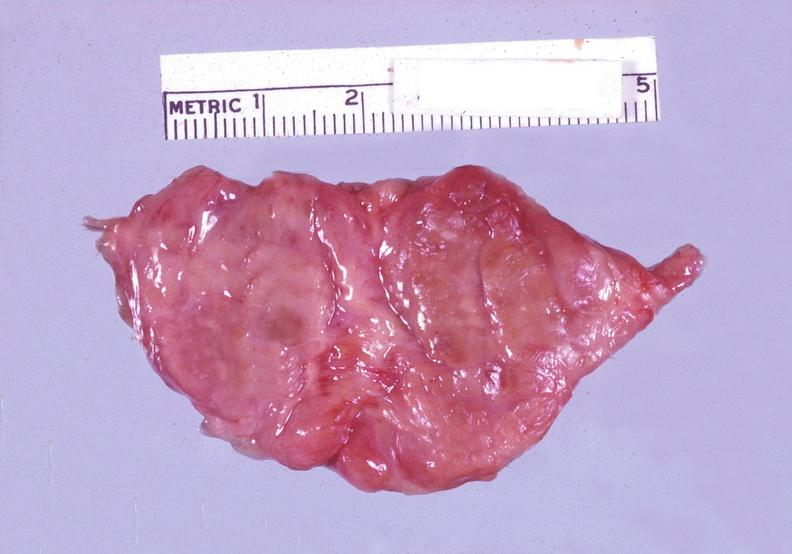what is present?
Answer the question using a single word or phrase. Endocrine 